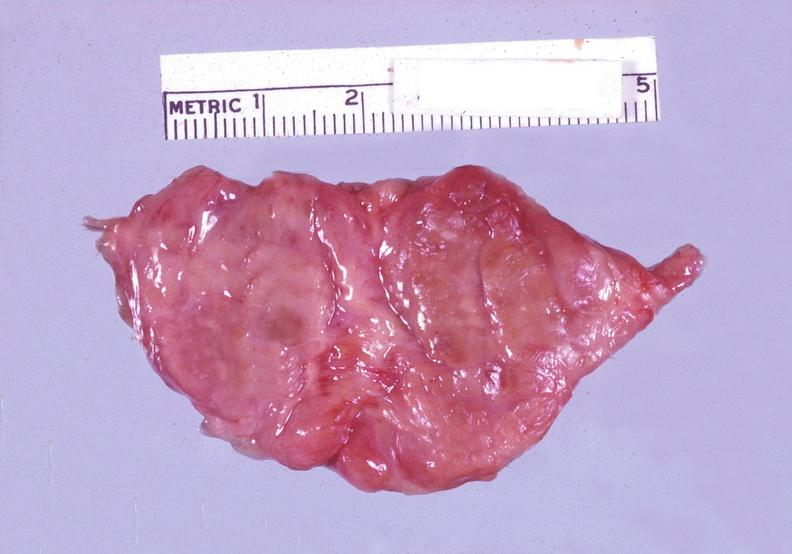what is present?
Answer the question using a single word or phrase. Endocrine 